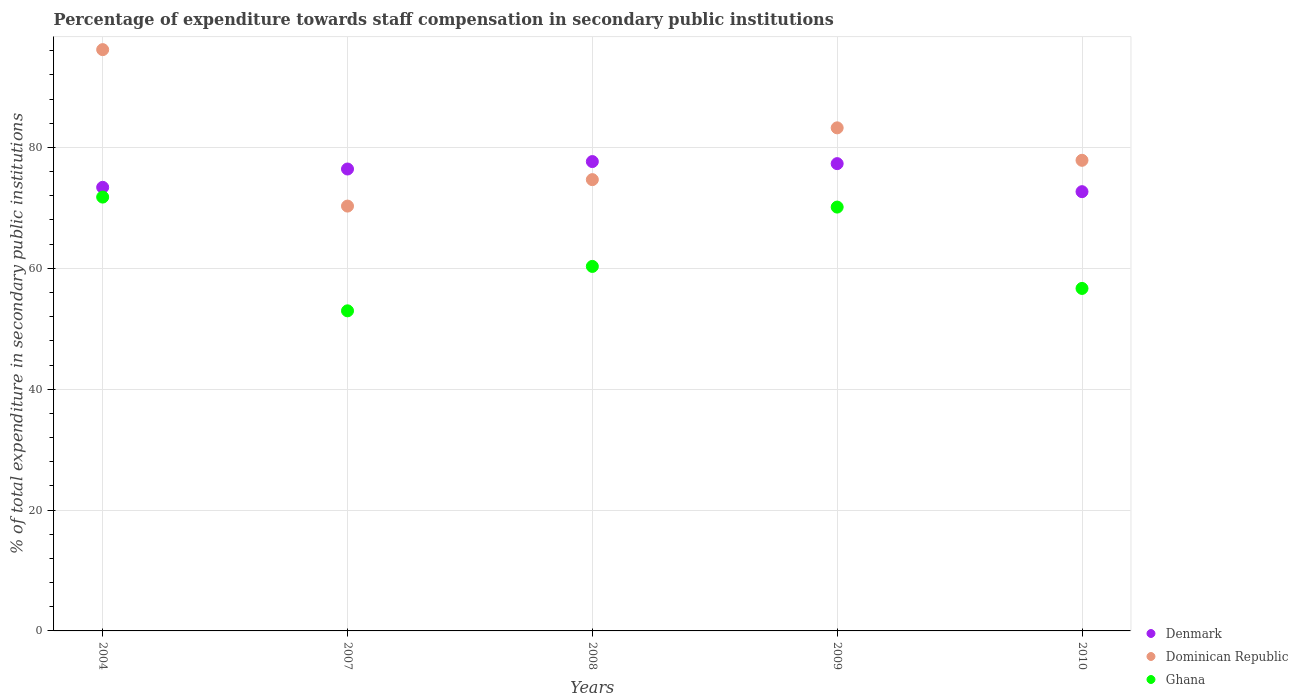How many different coloured dotlines are there?
Give a very brief answer. 3. Is the number of dotlines equal to the number of legend labels?
Your answer should be very brief. Yes. What is the percentage of expenditure towards staff compensation in Dominican Republic in 2007?
Offer a very short reply. 70.3. Across all years, what is the maximum percentage of expenditure towards staff compensation in Denmark?
Your response must be concise. 77.66. Across all years, what is the minimum percentage of expenditure towards staff compensation in Denmark?
Your response must be concise. 72.68. In which year was the percentage of expenditure towards staff compensation in Dominican Republic maximum?
Provide a short and direct response. 2004. What is the total percentage of expenditure towards staff compensation in Dominican Republic in the graph?
Offer a very short reply. 402.27. What is the difference between the percentage of expenditure towards staff compensation in Denmark in 2007 and that in 2009?
Give a very brief answer. -0.89. What is the difference between the percentage of expenditure towards staff compensation in Denmark in 2008 and the percentage of expenditure towards staff compensation in Dominican Republic in 2007?
Offer a very short reply. 7.37. What is the average percentage of expenditure towards staff compensation in Dominican Republic per year?
Provide a short and direct response. 80.45. In the year 2008, what is the difference between the percentage of expenditure towards staff compensation in Ghana and percentage of expenditure towards staff compensation in Denmark?
Your answer should be compact. -17.35. In how many years, is the percentage of expenditure towards staff compensation in Ghana greater than 64 %?
Your answer should be compact. 2. What is the ratio of the percentage of expenditure towards staff compensation in Denmark in 2007 to that in 2009?
Make the answer very short. 0.99. What is the difference between the highest and the second highest percentage of expenditure towards staff compensation in Denmark?
Your response must be concise. 0.34. What is the difference between the highest and the lowest percentage of expenditure towards staff compensation in Dominican Republic?
Make the answer very short. 25.89. Is the percentage of expenditure towards staff compensation in Dominican Republic strictly greater than the percentage of expenditure towards staff compensation in Ghana over the years?
Your answer should be compact. Yes. Is the percentage of expenditure towards staff compensation in Dominican Republic strictly less than the percentage of expenditure towards staff compensation in Denmark over the years?
Your answer should be compact. No. How many dotlines are there?
Your answer should be compact. 3. What is the difference between two consecutive major ticks on the Y-axis?
Your answer should be compact. 20. Are the values on the major ticks of Y-axis written in scientific E-notation?
Give a very brief answer. No. Where does the legend appear in the graph?
Offer a terse response. Bottom right. How are the legend labels stacked?
Make the answer very short. Vertical. What is the title of the graph?
Your answer should be very brief. Percentage of expenditure towards staff compensation in secondary public institutions. What is the label or title of the Y-axis?
Keep it short and to the point. % of total expenditure in secondary public institutions. What is the % of total expenditure in secondary public institutions of Denmark in 2004?
Ensure brevity in your answer.  73.4. What is the % of total expenditure in secondary public institutions in Dominican Republic in 2004?
Offer a terse response. 96.18. What is the % of total expenditure in secondary public institutions of Ghana in 2004?
Provide a succinct answer. 71.79. What is the % of total expenditure in secondary public institutions of Denmark in 2007?
Make the answer very short. 76.43. What is the % of total expenditure in secondary public institutions in Dominican Republic in 2007?
Provide a succinct answer. 70.3. What is the % of total expenditure in secondary public institutions in Ghana in 2007?
Your answer should be compact. 52.97. What is the % of total expenditure in secondary public institutions of Denmark in 2008?
Make the answer very short. 77.66. What is the % of total expenditure in secondary public institutions in Dominican Republic in 2008?
Ensure brevity in your answer.  74.67. What is the % of total expenditure in secondary public institutions of Ghana in 2008?
Ensure brevity in your answer.  60.31. What is the % of total expenditure in secondary public institutions in Denmark in 2009?
Your response must be concise. 77.32. What is the % of total expenditure in secondary public institutions of Dominican Republic in 2009?
Give a very brief answer. 83.24. What is the % of total expenditure in secondary public institutions of Ghana in 2009?
Provide a short and direct response. 70.13. What is the % of total expenditure in secondary public institutions of Denmark in 2010?
Ensure brevity in your answer.  72.68. What is the % of total expenditure in secondary public institutions in Dominican Republic in 2010?
Give a very brief answer. 77.87. What is the % of total expenditure in secondary public institutions of Ghana in 2010?
Give a very brief answer. 56.67. Across all years, what is the maximum % of total expenditure in secondary public institutions of Denmark?
Your answer should be compact. 77.66. Across all years, what is the maximum % of total expenditure in secondary public institutions of Dominican Republic?
Your answer should be very brief. 96.18. Across all years, what is the maximum % of total expenditure in secondary public institutions of Ghana?
Offer a terse response. 71.79. Across all years, what is the minimum % of total expenditure in secondary public institutions of Denmark?
Offer a terse response. 72.68. Across all years, what is the minimum % of total expenditure in secondary public institutions in Dominican Republic?
Offer a terse response. 70.3. Across all years, what is the minimum % of total expenditure in secondary public institutions of Ghana?
Offer a very short reply. 52.97. What is the total % of total expenditure in secondary public institutions of Denmark in the graph?
Give a very brief answer. 377.49. What is the total % of total expenditure in secondary public institutions in Dominican Republic in the graph?
Your response must be concise. 402.27. What is the total % of total expenditure in secondary public institutions of Ghana in the graph?
Your response must be concise. 311.87. What is the difference between the % of total expenditure in secondary public institutions of Denmark in 2004 and that in 2007?
Make the answer very short. -3.03. What is the difference between the % of total expenditure in secondary public institutions of Dominican Republic in 2004 and that in 2007?
Make the answer very short. 25.89. What is the difference between the % of total expenditure in secondary public institutions in Ghana in 2004 and that in 2007?
Your answer should be very brief. 18.82. What is the difference between the % of total expenditure in secondary public institutions of Denmark in 2004 and that in 2008?
Offer a terse response. -4.26. What is the difference between the % of total expenditure in secondary public institutions in Dominican Republic in 2004 and that in 2008?
Your answer should be compact. 21.51. What is the difference between the % of total expenditure in secondary public institutions of Ghana in 2004 and that in 2008?
Offer a very short reply. 11.47. What is the difference between the % of total expenditure in secondary public institutions in Denmark in 2004 and that in 2009?
Offer a terse response. -3.92. What is the difference between the % of total expenditure in secondary public institutions of Dominican Republic in 2004 and that in 2009?
Your response must be concise. 12.94. What is the difference between the % of total expenditure in secondary public institutions in Ghana in 2004 and that in 2009?
Your answer should be compact. 1.65. What is the difference between the % of total expenditure in secondary public institutions of Denmark in 2004 and that in 2010?
Your response must be concise. 0.72. What is the difference between the % of total expenditure in secondary public institutions in Dominican Republic in 2004 and that in 2010?
Give a very brief answer. 18.31. What is the difference between the % of total expenditure in secondary public institutions in Ghana in 2004 and that in 2010?
Offer a terse response. 15.11. What is the difference between the % of total expenditure in secondary public institutions of Denmark in 2007 and that in 2008?
Provide a short and direct response. -1.23. What is the difference between the % of total expenditure in secondary public institutions in Dominican Republic in 2007 and that in 2008?
Your answer should be very brief. -4.38. What is the difference between the % of total expenditure in secondary public institutions of Ghana in 2007 and that in 2008?
Your answer should be very brief. -7.35. What is the difference between the % of total expenditure in secondary public institutions in Denmark in 2007 and that in 2009?
Give a very brief answer. -0.89. What is the difference between the % of total expenditure in secondary public institutions of Dominican Republic in 2007 and that in 2009?
Your answer should be very brief. -12.95. What is the difference between the % of total expenditure in secondary public institutions in Ghana in 2007 and that in 2009?
Make the answer very short. -17.17. What is the difference between the % of total expenditure in secondary public institutions in Denmark in 2007 and that in 2010?
Keep it short and to the point. 3.75. What is the difference between the % of total expenditure in secondary public institutions of Dominican Republic in 2007 and that in 2010?
Ensure brevity in your answer.  -7.58. What is the difference between the % of total expenditure in secondary public institutions in Ghana in 2007 and that in 2010?
Give a very brief answer. -3.71. What is the difference between the % of total expenditure in secondary public institutions in Denmark in 2008 and that in 2009?
Your response must be concise. 0.34. What is the difference between the % of total expenditure in secondary public institutions of Dominican Republic in 2008 and that in 2009?
Provide a short and direct response. -8.57. What is the difference between the % of total expenditure in secondary public institutions of Ghana in 2008 and that in 2009?
Your answer should be compact. -9.82. What is the difference between the % of total expenditure in secondary public institutions of Denmark in 2008 and that in 2010?
Ensure brevity in your answer.  4.98. What is the difference between the % of total expenditure in secondary public institutions in Dominican Republic in 2008 and that in 2010?
Give a very brief answer. -3.2. What is the difference between the % of total expenditure in secondary public institutions in Ghana in 2008 and that in 2010?
Offer a very short reply. 3.64. What is the difference between the % of total expenditure in secondary public institutions in Denmark in 2009 and that in 2010?
Provide a short and direct response. 4.64. What is the difference between the % of total expenditure in secondary public institutions of Dominican Republic in 2009 and that in 2010?
Give a very brief answer. 5.37. What is the difference between the % of total expenditure in secondary public institutions of Ghana in 2009 and that in 2010?
Your answer should be very brief. 13.46. What is the difference between the % of total expenditure in secondary public institutions of Denmark in 2004 and the % of total expenditure in secondary public institutions of Dominican Republic in 2007?
Your response must be concise. 3.1. What is the difference between the % of total expenditure in secondary public institutions in Denmark in 2004 and the % of total expenditure in secondary public institutions in Ghana in 2007?
Your answer should be compact. 20.43. What is the difference between the % of total expenditure in secondary public institutions in Dominican Republic in 2004 and the % of total expenditure in secondary public institutions in Ghana in 2007?
Offer a terse response. 43.22. What is the difference between the % of total expenditure in secondary public institutions in Denmark in 2004 and the % of total expenditure in secondary public institutions in Dominican Republic in 2008?
Your answer should be very brief. -1.27. What is the difference between the % of total expenditure in secondary public institutions in Denmark in 2004 and the % of total expenditure in secondary public institutions in Ghana in 2008?
Your response must be concise. 13.09. What is the difference between the % of total expenditure in secondary public institutions in Dominican Republic in 2004 and the % of total expenditure in secondary public institutions in Ghana in 2008?
Your answer should be compact. 35.87. What is the difference between the % of total expenditure in secondary public institutions of Denmark in 2004 and the % of total expenditure in secondary public institutions of Dominican Republic in 2009?
Ensure brevity in your answer.  -9.84. What is the difference between the % of total expenditure in secondary public institutions of Denmark in 2004 and the % of total expenditure in secondary public institutions of Ghana in 2009?
Provide a succinct answer. 3.27. What is the difference between the % of total expenditure in secondary public institutions in Dominican Republic in 2004 and the % of total expenditure in secondary public institutions in Ghana in 2009?
Provide a succinct answer. 26.05. What is the difference between the % of total expenditure in secondary public institutions in Denmark in 2004 and the % of total expenditure in secondary public institutions in Dominican Republic in 2010?
Ensure brevity in your answer.  -4.47. What is the difference between the % of total expenditure in secondary public institutions in Denmark in 2004 and the % of total expenditure in secondary public institutions in Ghana in 2010?
Give a very brief answer. 16.73. What is the difference between the % of total expenditure in secondary public institutions in Dominican Republic in 2004 and the % of total expenditure in secondary public institutions in Ghana in 2010?
Your response must be concise. 39.51. What is the difference between the % of total expenditure in secondary public institutions of Denmark in 2007 and the % of total expenditure in secondary public institutions of Dominican Republic in 2008?
Ensure brevity in your answer.  1.76. What is the difference between the % of total expenditure in secondary public institutions of Denmark in 2007 and the % of total expenditure in secondary public institutions of Ghana in 2008?
Give a very brief answer. 16.12. What is the difference between the % of total expenditure in secondary public institutions in Dominican Republic in 2007 and the % of total expenditure in secondary public institutions in Ghana in 2008?
Give a very brief answer. 9.98. What is the difference between the % of total expenditure in secondary public institutions in Denmark in 2007 and the % of total expenditure in secondary public institutions in Dominican Republic in 2009?
Offer a terse response. -6.81. What is the difference between the % of total expenditure in secondary public institutions in Denmark in 2007 and the % of total expenditure in secondary public institutions in Ghana in 2009?
Provide a short and direct response. 6.3. What is the difference between the % of total expenditure in secondary public institutions of Dominican Republic in 2007 and the % of total expenditure in secondary public institutions of Ghana in 2009?
Make the answer very short. 0.17. What is the difference between the % of total expenditure in secondary public institutions in Denmark in 2007 and the % of total expenditure in secondary public institutions in Dominican Republic in 2010?
Your answer should be very brief. -1.44. What is the difference between the % of total expenditure in secondary public institutions of Denmark in 2007 and the % of total expenditure in secondary public institutions of Ghana in 2010?
Give a very brief answer. 19.76. What is the difference between the % of total expenditure in secondary public institutions in Dominican Republic in 2007 and the % of total expenditure in secondary public institutions in Ghana in 2010?
Your answer should be compact. 13.62. What is the difference between the % of total expenditure in secondary public institutions in Denmark in 2008 and the % of total expenditure in secondary public institutions in Dominican Republic in 2009?
Keep it short and to the point. -5.58. What is the difference between the % of total expenditure in secondary public institutions of Denmark in 2008 and the % of total expenditure in secondary public institutions of Ghana in 2009?
Your answer should be compact. 7.53. What is the difference between the % of total expenditure in secondary public institutions in Dominican Republic in 2008 and the % of total expenditure in secondary public institutions in Ghana in 2009?
Ensure brevity in your answer.  4.54. What is the difference between the % of total expenditure in secondary public institutions in Denmark in 2008 and the % of total expenditure in secondary public institutions in Dominican Republic in 2010?
Your answer should be very brief. -0.21. What is the difference between the % of total expenditure in secondary public institutions of Denmark in 2008 and the % of total expenditure in secondary public institutions of Ghana in 2010?
Offer a very short reply. 20.99. What is the difference between the % of total expenditure in secondary public institutions in Dominican Republic in 2008 and the % of total expenditure in secondary public institutions in Ghana in 2010?
Keep it short and to the point. 18. What is the difference between the % of total expenditure in secondary public institutions of Denmark in 2009 and the % of total expenditure in secondary public institutions of Dominican Republic in 2010?
Provide a short and direct response. -0.55. What is the difference between the % of total expenditure in secondary public institutions in Denmark in 2009 and the % of total expenditure in secondary public institutions in Ghana in 2010?
Provide a succinct answer. 20.65. What is the difference between the % of total expenditure in secondary public institutions of Dominican Republic in 2009 and the % of total expenditure in secondary public institutions of Ghana in 2010?
Provide a short and direct response. 26.57. What is the average % of total expenditure in secondary public institutions of Denmark per year?
Ensure brevity in your answer.  75.5. What is the average % of total expenditure in secondary public institutions of Dominican Republic per year?
Provide a short and direct response. 80.45. What is the average % of total expenditure in secondary public institutions in Ghana per year?
Provide a succinct answer. 62.37. In the year 2004, what is the difference between the % of total expenditure in secondary public institutions in Denmark and % of total expenditure in secondary public institutions in Dominican Republic?
Offer a very short reply. -22.78. In the year 2004, what is the difference between the % of total expenditure in secondary public institutions in Denmark and % of total expenditure in secondary public institutions in Ghana?
Offer a terse response. 1.61. In the year 2004, what is the difference between the % of total expenditure in secondary public institutions of Dominican Republic and % of total expenditure in secondary public institutions of Ghana?
Ensure brevity in your answer.  24.4. In the year 2007, what is the difference between the % of total expenditure in secondary public institutions of Denmark and % of total expenditure in secondary public institutions of Dominican Republic?
Make the answer very short. 6.13. In the year 2007, what is the difference between the % of total expenditure in secondary public institutions of Denmark and % of total expenditure in secondary public institutions of Ghana?
Your answer should be compact. 23.47. In the year 2007, what is the difference between the % of total expenditure in secondary public institutions of Dominican Republic and % of total expenditure in secondary public institutions of Ghana?
Your answer should be very brief. 17.33. In the year 2008, what is the difference between the % of total expenditure in secondary public institutions in Denmark and % of total expenditure in secondary public institutions in Dominican Republic?
Offer a very short reply. 2.99. In the year 2008, what is the difference between the % of total expenditure in secondary public institutions in Denmark and % of total expenditure in secondary public institutions in Ghana?
Offer a very short reply. 17.35. In the year 2008, what is the difference between the % of total expenditure in secondary public institutions in Dominican Republic and % of total expenditure in secondary public institutions in Ghana?
Provide a succinct answer. 14.36. In the year 2009, what is the difference between the % of total expenditure in secondary public institutions in Denmark and % of total expenditure in secondary public institutions in Dominican Republic?
Provide a short and direct response. -5.92. In the year 2009, what is the difference between the % of total expenditure in secondary public institutions of Denmark and % of total expenditure in secondary public institutions of Ghana?
Give a very brief answer. 7.19. In the year 2009, what is the difference between the % of total expenditure in secondary public institutions of Dominican Republic and % of total expenditure in secondary public institutions of Ghana?
Keep it short and to the point. 13.11. In the year 2010, what is the difference between the % of total expenditure in secondary public institutions in Denmark and % of total expenditure in secondary public institutions in Dominican Republic?
Ensure brevity in your answer.  -5.19. In the year 2010, what is the difference between the % of total expenditure in secondary public institutions in Denmark and % of total expenditure in secondary public institutions in Ghana?
Provide a short and direct response. 16.01. In the year 2010, what is the difference between the % of total expenditure in secondary public institutions in Dominican Republic and % of total expenditure in secondary public institutions in Ghana?
Ensure brevity in your answer.  21.2. What is the ratio of the % of total expenditure in secondary public institutions in Denmark in 2004 to that in 2007?
Offer a very short reply. 0.96. What is the ratio of the % of total expenditure in secondary public institutions of Dominican Republic in 2004 to that in 2007?
Provide a succinct answer. 1.37. What is the ratio of the % of total expenditure in secondary public institutions of Ghana in 2004 to that in 2007?
Keep it short and to the point. 1.36. What is the ratio of the % of total expenditure in secondary public institutions in Denmark in 2004 to that in 2008?
Provide a succinct answer. 0.95. What is the ratio of the % of total expenditure in secondary public institutions of Dominican Republic in 2004 to that in 2008?
Your response must be concise. 1.29. What is the ratio of the % of total expenditure in secondary public institutions of Ghana in 2004 to that in 2008?
Keep it short and to the point. 1.19. What is the ratio of the % of total expenditure in secondary public institutions of Denmark in 2004 to that in 2009?
Provide a succinct answer. 0.95. What is the ratio of the % of total expenditure in secondary public institutions in Dominican Republic in 2004 to that in 2009?
Give a very brief answer. 1.16. What is the ratio of the % of total expenditure in secondary public institutions in Ghana in 2004 to that in 2009?
Give a very brief answer. 1.02. What is the ratio of the % of total expenditure in secondary public institutions in Denmark in 2004 to that in 2010?
Ensure brevity in your answer.  1.01. What is the ratio of the % of total expenditure in secondary public institutions of Dominican Republic in 2004 to that in 2010?
Your answer should be very brief. 1.24. What is the ratio of the % of total expenditure in secondary public institutions in Ghana in 2004 to that in 2010?
Provide a short and direct response. 1.27. What is the ratio of the % of total expenditure in secondary public institutions in Denmark in 2007 to that in 2008?
Your answer should be very brief. 0.98. What is the ratio of the % of total expenditure in secondary public institutions in Dominican Republic in 2007 to that in 2008?
Keep it short and to the point. 0.94. What is the ratio of the % of total expenditure in secondary public institutions in Ghana in 2007 to that in 2008?
Give a very brief answer. 0.88. What is the ratio of the % of total expenditure in secondary public institutions of Dominican Republic in 2007 to that in 2009?
Your response must be concise. 0.84. What is the ratio of the % of total expenditure in secondary public institutions of Ghana in 2007 to that in 2009?
Provide a short and direct response. 0.76. What is the ratio of the % of total expenditure in secondary public institutions of Denmark in 2007 to that in 2010?
Ensure brevity in your answer.  1.05. What is the ratio of the % of total expenditure in secondary public institutions of Dominican Republic in 2007 to that in 2010?
Make the answer very short. 0.9. What is the ratio of the % of total expenditure in secondary public institutions of Ghana in 2007 to that in 2010?
Provide a succinct answer. 0.93. What is the ratio of the % of total expenditure in secondary public institutions of Dominican Republic in 2008 to that in 2009?
Make the answer very short. 0.9. What is the ratio of the % of total expenditure in secondary public institutions of Ghana in 2008 to that in 2009?
Make the answer very short. 0.86. What is the ratio of the % of total expenditure in secondary public institutions in Denmark in 2008 to that in 2010?
Your answer should be very brief. 1.07. What is the ratio of the % of total expenditure in secondary public institutions of Dominican Republic in 2008 to that in 2010?
Your answer should be compact. 0.96. What is the ratio of the % of total expenditure in secondary public institutions of Ghana in 2008 to that in 2010?
Your answer should be very brief. 1.06. What is the ratio of the % of total expenditure in secondary public institutions in Denmark in 2009 to that in 2010?
Ensure brevity in your answer.  1.06. What is the ratio of the % of total expenditure in secondary public institutions of Dominican Republic in 2009 to that in 2010?
Your response must be concise. 1.07. What is the ratio of the % of total expenditure in secondary public institutions in Ghana in 2009 to that in 2010?
Provide a succinct answer. 1.24. What is the difference between the highest and the second highest % of total expenditure in secondary public institutions of Denmark?
Give a very brief answer. 0.34. What is the difference between the highest and the second highest % of total expenditure in secondary public institutions in Dominican Republic?
Offer a very short reply. 12.94. What is the difference between the highest and the second highest % of total expenditure in secondary public institutions in Ghana?
Your response must be concise. 1.65. What is the difference between the highest and the lowest % of total expenditure in secondary public institutions of Denmark?
Give a very brief answer. 4.98. What is the difference between the highest and the lowest % of total expenditure in secondary public institutions of Dominican Republic?
Provide a succinct answer. 25.89. What is the difference between the highest and the lowest % of total expenditure in secondary public institutions of Ghana?
Keep it short and to the point. 18.82. 